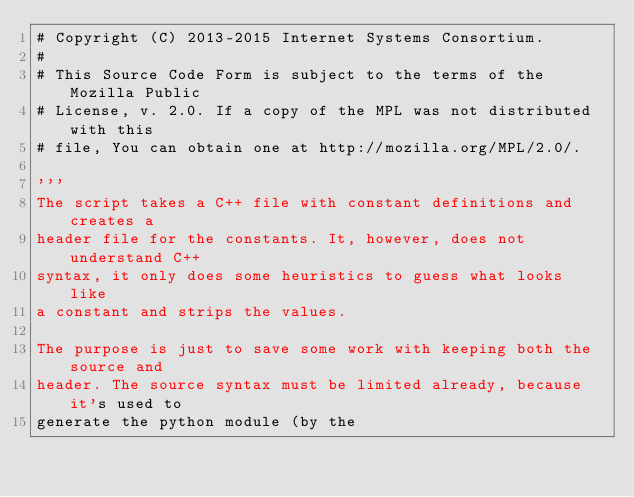<code> <loc_0><loc_0><loc_500><loc_500><_Python_># Copyright (C) 2013-2015 Internet Systems Consortium.
#
# This Source Code Form is subject to the terms of the Mozilla Public
# License, v. 2.0. If a copy of the MPL was not distributed with this
# file, You can obtain one at http://mozilla.org/MPL/2.0/.

'''
The script takes a C++ file with constant definitions and creates a
header file for the constants. It, however, does not understand C++
syntax, it only does some heuristics to guess what looks like
a constant and strips the values.

The purpose is just to save some work with keeping both the source and
header. The source syntax must be limited already, because it's used to
generate the python module (by the</code> 